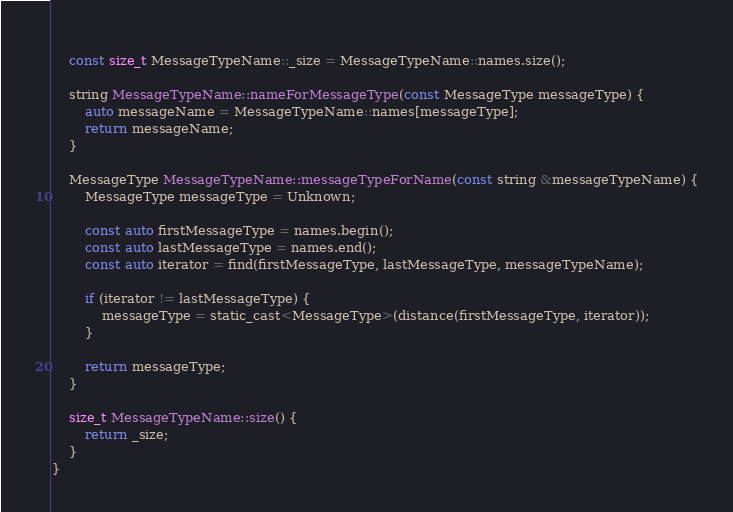<code> <loc_0><loc_0><loc_500><loc_500><_ObjectiveC_>    
    const size_t MessageTypeName::_size = MessageTypeName::names.size();
    
    string MessageTypeName::nameForMessageType(const MessageType messageType) {
        auto messageName = MessageTypeName::names[messageType];
        return messageName;
    }
    
    MessageType MessageTypeName::messageTypeForName(const string &messageTypeName) {
        MessageType messageType = Unknown;
        
        const auto firstMessageType = names.begin();
        const auto lastMessageType = names.end();
        const auto iterator = find(firstMessageType, lastMessageType, messageTypeName);
        
        if (iterator != lastMessageType) {
            messageType = static_cast<MessageType>(distance(firstMessageType, iterator));
        }
        
        return messageType;
    }
    
    size_t MessageTypeName::size() {
        return _size;
    }
}
</code> 